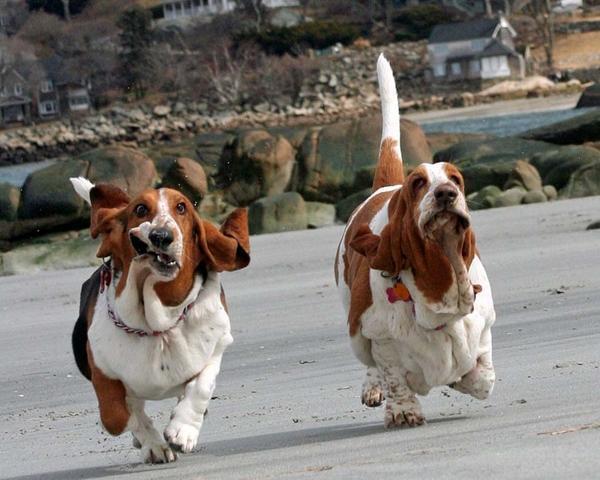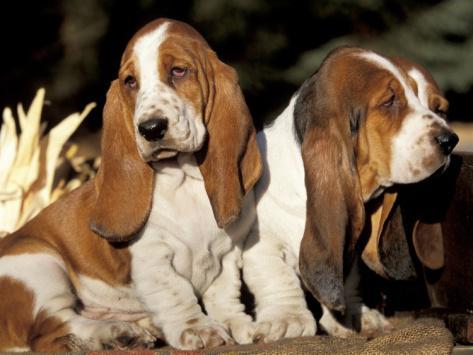The first image is the image on the left, the second image is the image on the right. Considering the images on both sides, is "One image shows a large basset hound on green grass, with at least one smaller hound touching it, and the other image features exactly two hounds side-by-side." valid? Answer yes or no. No. The first image is the image on the left, the second image is the image on the right. Assess this claim about the two images: "The dogs in the image on the right are outside in the grass.". Correct or not? Answer yes or no. No. 